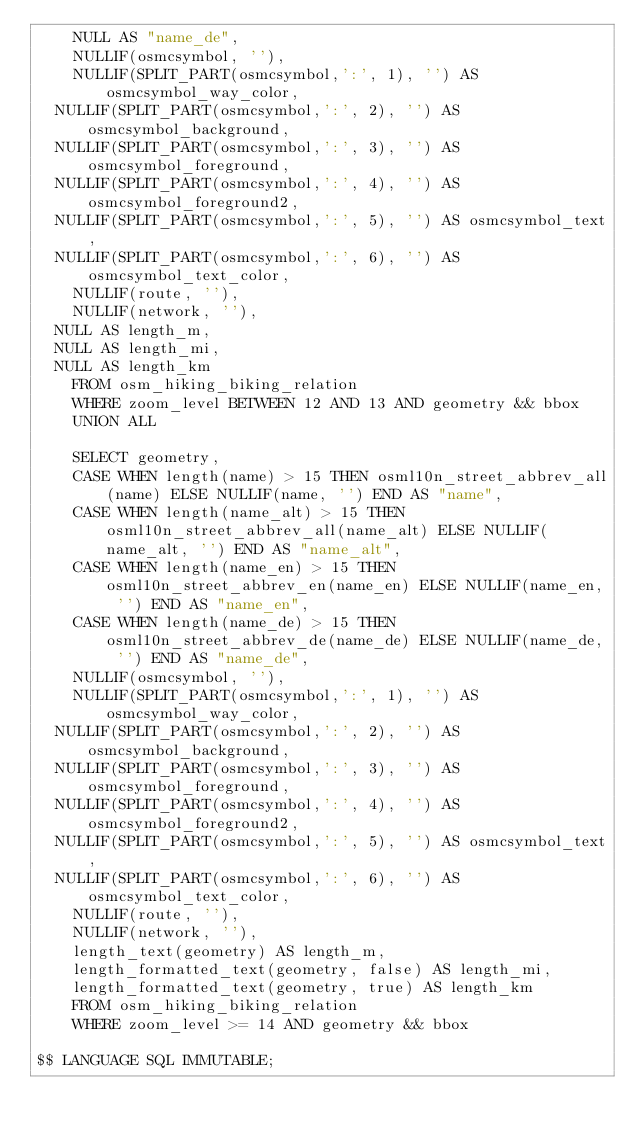<code> <loc_0><loc_0><loc_500><loc_500><_SQL_>    NULL AS "name_de",
    NULLIF(osmcsymbol, ''),
    NULLIF(SPLIT_PART(osmcsymbol,':', 1), '') AS osmcsymbol_way_color,
	NULLIF(SPLIT_PART(osmcsymbol,':', 2), '') AS osmcsymbol_background,
	NULLIF(SPLIT_PART(osmcsymbol,':', 3), '') AS osmcsymbol_foreground,
	NULLIF(SPLIT_PART(osmcsymbol,':', 4), '') AS osmcsymbol_foreground2,
	NULLIF(SPLIT_PART(osmcsymbol,':', 5), '') AS osmcsymbol_text,
	NULLIF(SPLIT_PART(osmcsymbol,':', 6), '') AS osmcsymbol_text_color,
    NULLIF(route, ''), 
    NULLIF(network, ''),
	NULL AS length_m,
	NULL AS length_mi,
	NULL AS length_km
    FROM osm_hiking_biking_relation
    WHERE zoom_level BETWEEN 12 AND 13 AND geometry && bbox
    UNION ALL
    	
    SELECT geometry, 
    CASE WHEN length(name) > 15 THEN osml10n_street_abbrev_all(name) ELSE NULLIF(name, '') END AS "name",
    CASE WHEN length(name_alt) > 15 THEN osml10n_street_abbrev_all(name_alt) ELSE NULLIF(name_alt, '') END AS "name_alt",
    CASE WHEN length(name_en) > 15 THEN osml10n_street_abbrev_en(name_en) ELSE NULLIF(name_en, '') END AS "name_en",
    CASE WHEN length(name_de) > 15 THEN osml10n_street_abbrev_de(name_de) ELSE NULLIF(name_de, '') END AS "name_de",
    NULLIF(osmcsymbol, ''),
    NULLIF(SPLIT_PART(osmcsymbol,':', 1), '') AS osmcsymbol_way_color,
	NULLIF(SPLIT_PART(osmcsymbol,':', 2), '') AS osmcsymbol_background,
	NULLIF(SPLIT_PART(osmcsymbol,':', 3), '') AS osmcsymbol_foreground,
	NULLIF(SPLIT_PART(osmcsymbol,':', 4), '') AS osmcsymbol_foreground2,
	NULLIF(SPLIT_PART(osmcsymbol,':', 5), '') AS osmcsymbol_text,
	NULLIF(SPLIT_PART(osmcsymbol,':', 6), '') AS osmcsymbol_text_color,
    NULLIF(route, ''), 
    NULLIF(network, ''),
   	length_text(geometry) AS length_m,
   	length_formatted_text(geometry, false) AS length_mi,
   	length_formatted_text(geometry, true) AS length_km
    FROM osm_hiking_biking_relation
    WHERE zoom_level >= 14 AND geometry && bbox
    
$$ LANGUAGE SQL IMMUTABLE;
</code> 